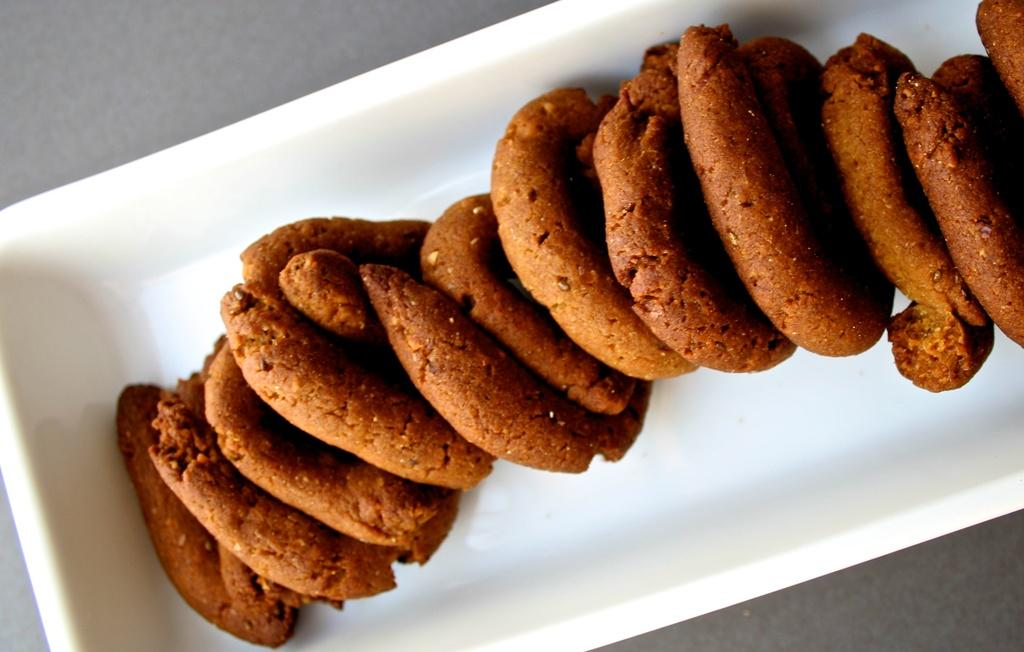What type of food can be seen in the image? There are cookies in the image. How are the cookies packaged? The cookies are in a white color box. Where is the box of cookies located? The box is placed on a table. What is the color of the cookies? The cookies are in brown color. What type of pot is visible in the image? There is no pot present in the image; it features a box of cookies on a table. What message of peace can be seen in the image? There is no message of peace present in the image; it only shows a box of cookies on a table. 